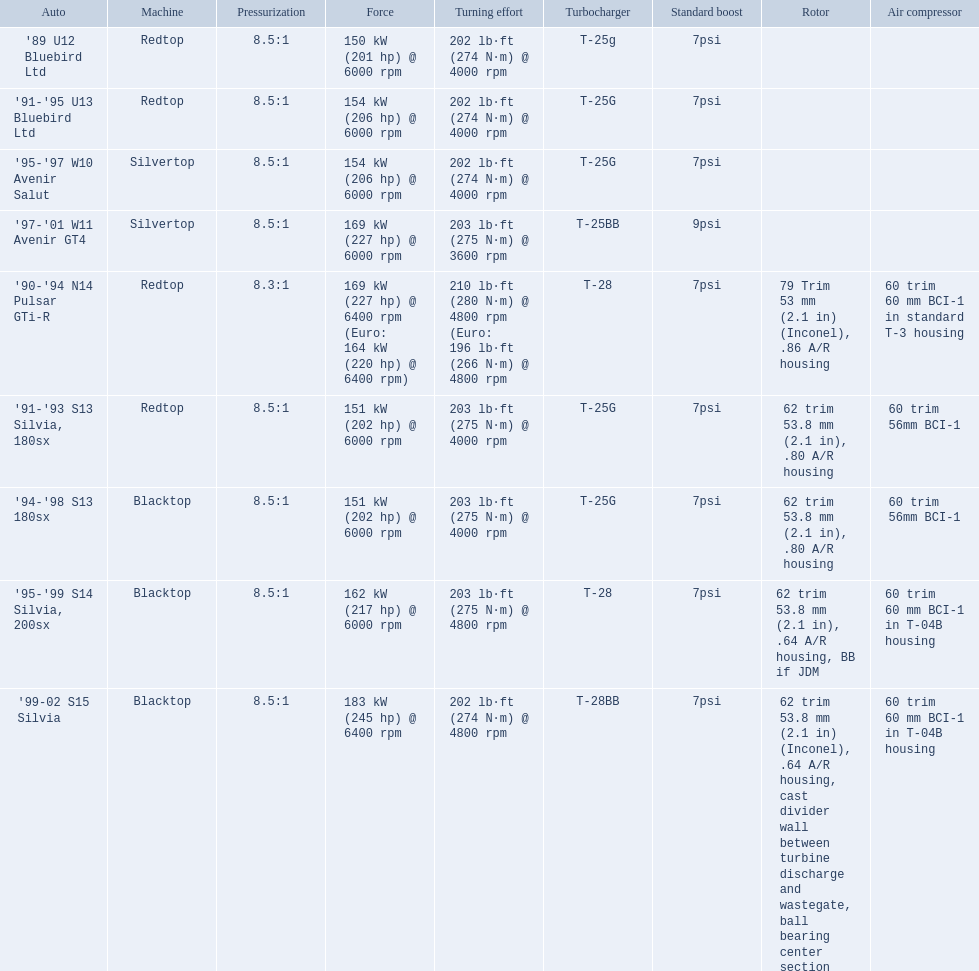Which cars featured blacktop engines? '94-'98 S13 180sx, '95-'99 S14 Silvia, 200sx, '99-02 S15 Silvia. Which of these had t-04b compressor housings? '95-'99 S14 Silvia, 200sx, '99-02 S15 Silvia. Which one of these has the highest horsepower? '99-02 S15 Silvia. What cars are there? '89 U12 Bluebird Ltd, 7psi, '91-'95 U13 Bluebird Ltd, 7psi, '95-'97 W10 Avenir Salut, 7psi, '97-'01 W11 Avenir GT4, 9psi, '90-'94 N14 Pulsar GTi-R, 7psi, '91-'93 S13 Silvia, 180sx, 7psi, '94-'98 S13 180sx, 7psi, '95-'99 S14 Silvia, 200sx, 7psi, '99-02 S15 Silvia, 7psi. Which stock boost is over 7psi? '97-'01 W11 Avenir GT4, 9psi. What car is it? '97-'01 W11 Avenir GT4. 